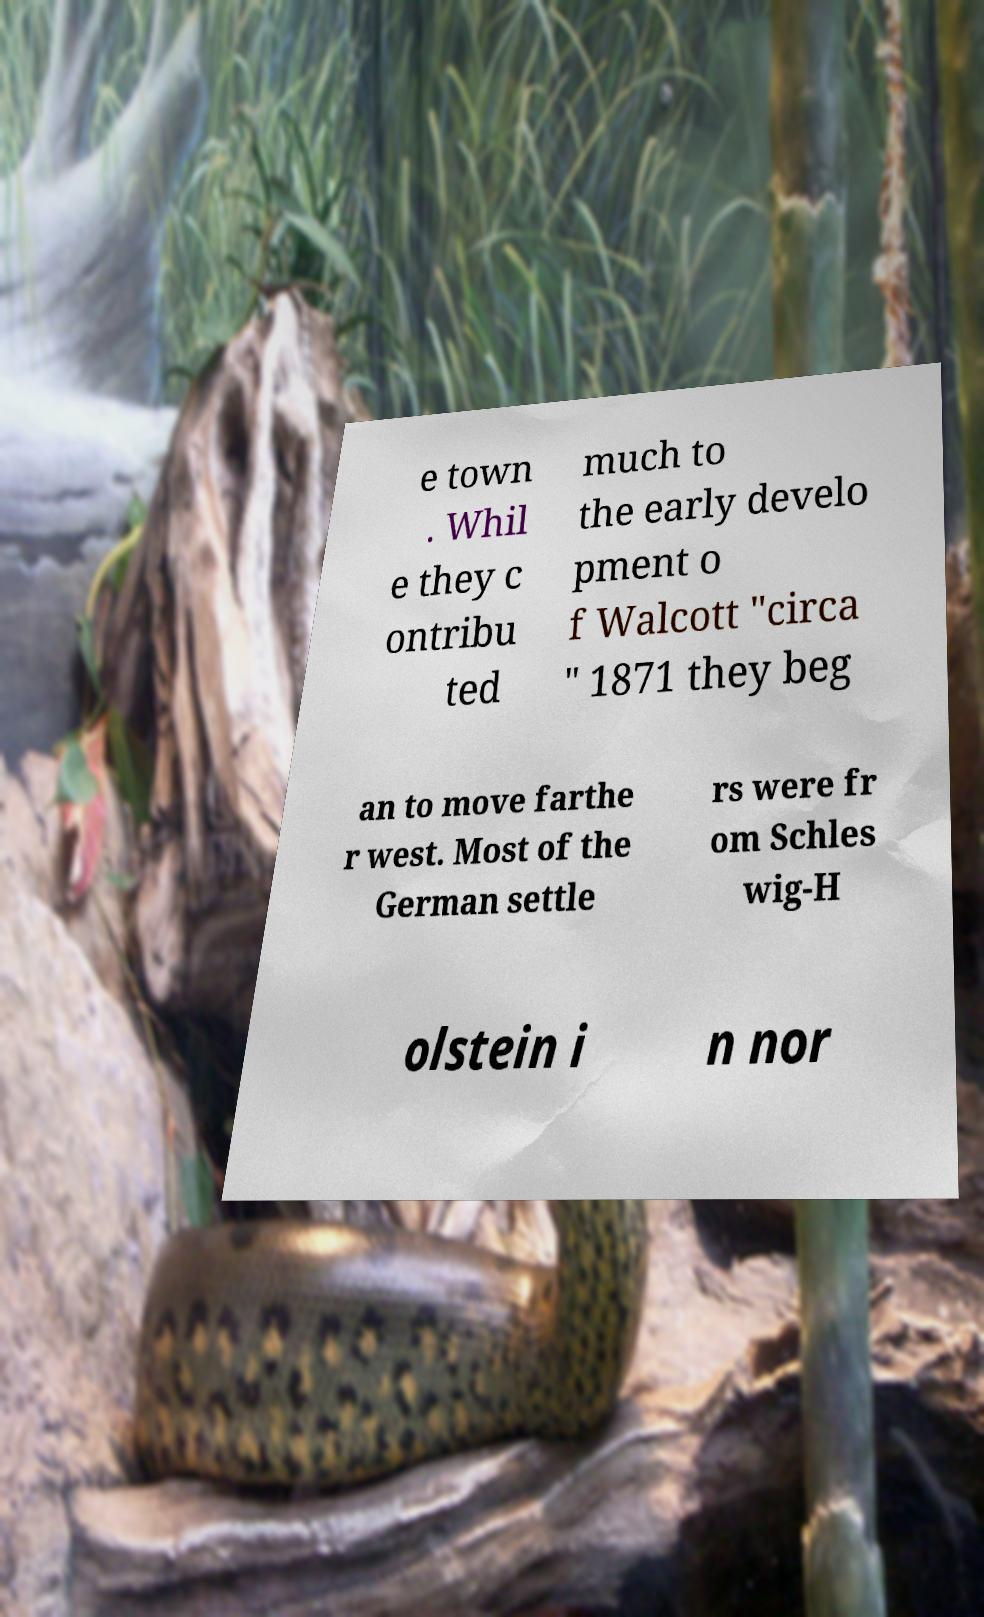For documentation purposes, I need the text within this image transcribed. Could you provide that? e town . Whil e they c ontribu ted much to the early develo pment o f Walcott "circa " 1871 they beg an to move farthe r west. Most of the German settle rs were fr om Schles wig-H olstein i n nor 